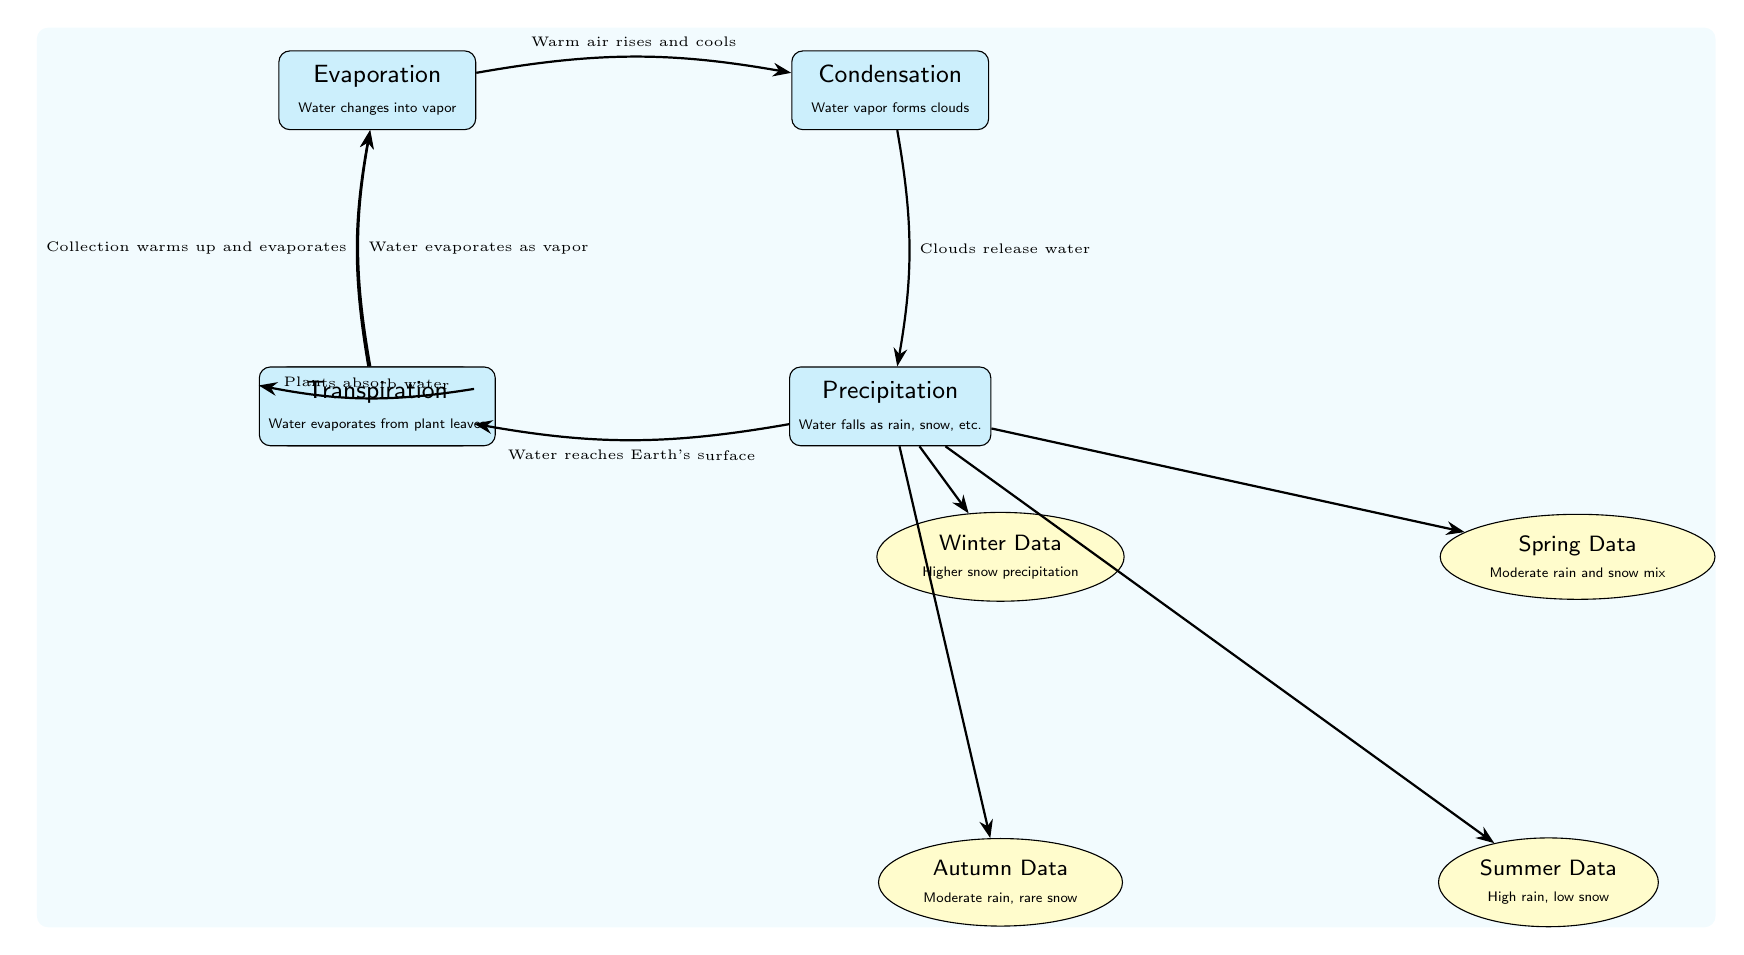What is the node that represents the process of water falling? The diagram includes a node labeled "Precipitation," which describes the process of water falling to the Earth's surface in various forms such as rain, snow, etc.
Answer: Precipitation Which season data indicates higher snow precipitation? The node for season data labeled "Winter Data" specifically mentions higher snow precipitation, distinguishing it from the other seasons represented in the diagram.
Answer: Winter Data How many main processes are shown in the water cycle? The diagram illustrates five main processes, which are evaporation, condensation, precipitation, collection, and transpiration, all depicted as distinct nodes in the cycle.
Answer: Five What is the flow direction from condensation to precipitation? The diagram shows a directed edge with the label "Clouds release water," clearly indicating the flow from condensation to precipitation, which is part of the water cycle.
Answer: Clouds release water What is the season data associated with moderate rain and rare snow? The node labeled "Autumn Data" is associated with moderate rain and rare snow, as indicated by the description under that specific node in the diagram.
Answer: Autumn Data How does collection influence evaporation? The diagram indicates that collection, which represents water accumulating in bodies, warms up and then contributes to evaporation, thus completing the cycle back to evaporation.
Answer: Collection warms up and evaporates What is the connection between transpiration and evaporation in the diagram? The diagram shows that transpiration involves water evaporating from plant leaves, which contributes directly to the evaporation process mentioned elsewhere in the water cycle.
Answer: Water evaporates as vapor Which season is associated with high rain and low snow? The diagram contains a season labeled "Summer Data," indicating that this season is characterized by high rainfall and minimal snowfall according to the description provided in that node.
Answer: Summer Data What process occurs after precipitation according to the diagram? After precipitation, the diagram indicates that water reaches the Earth's surface, which corresponds to the collection process where water accumulates in various bodies.
Answer: Water reaches Earth's surface 